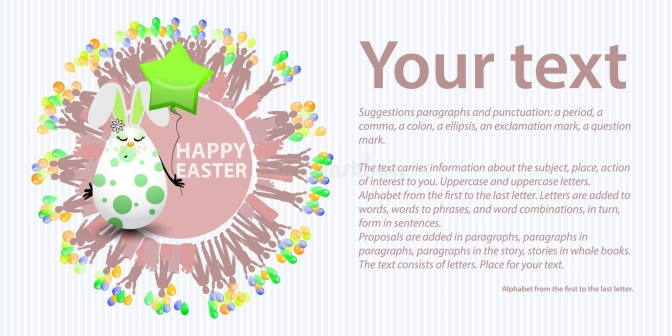Imagine if the Easter bunny was actually on a secret mission. What could it be? Deep within the enchanted woods, Pip the Easter bunny embarked on a secret mission unknown to many. The magical meadow had been losing its vibrant colors, and it was up to Pip to restore them. Guided by an ancient map that led to the fabled Rainbow Crystal, Pip journeyed through mystical lands, solving puzzles and overcoming challenges. Along the way, Pip met helpers like Lumi the firefly, who illuminated dark paths, and Whisk the owl, who provided wisdom. Finally reaching the hidden cave, Pip discovered the Rainbow Crystal guarded by a slumbering dragon. Using kindness and charm, Pip managed to make friends with the dragon and retrieve the crystal. With a single touch, the crystal’s magic burst forth, revitalizing the meadow with a cascade of colors. As Pip returned, holding the star-shaped balloon as a sign of unity, a grand celebration erupted, marking the triumph of Pip and the return of the meadow's glorious hues. The text box, now glowing, read, 'Colors of Friendship Restored!' 